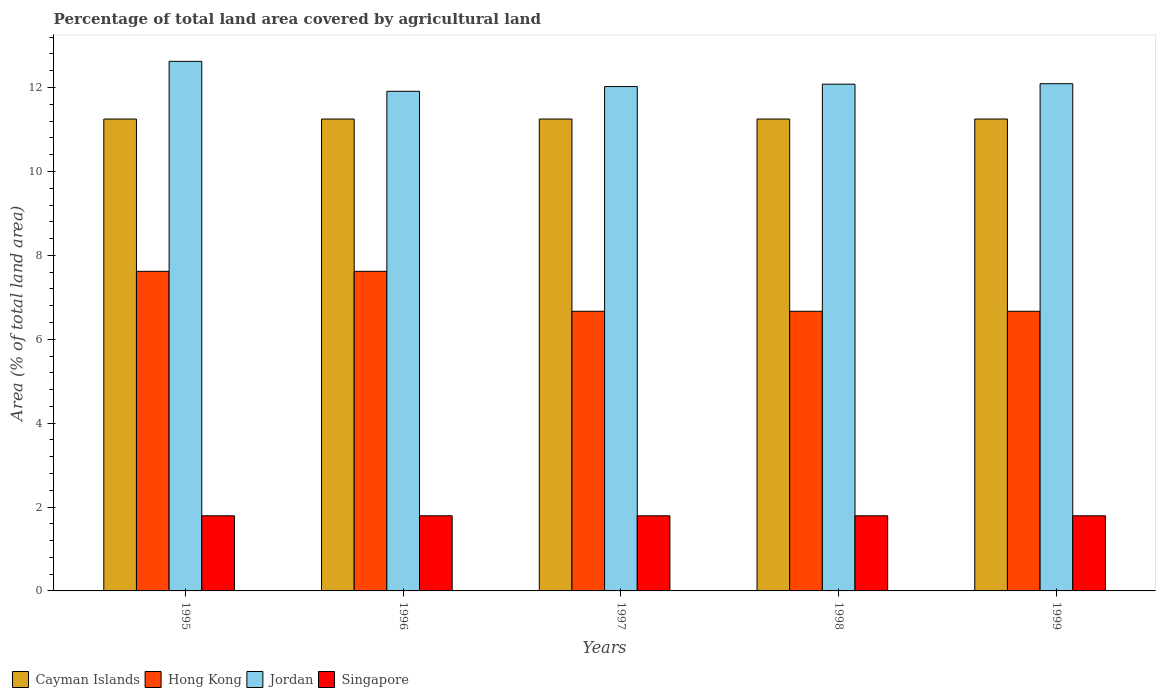How many groups of bars are there?
Give a very brief answer. 5. How many bars are there on the 1st tick from the left?
Offer a terse response. 4. How many bars are there on the 1st tick from the right?
Provide a succinct answer. 4. In how many cases, is the number of bars for a given year not equal to the number of legend labels?
Your answer should be compact. 0. What is the percentage of agricultural land in Hong Kong in 1997?
Your answer should be compact. 6.67. Across all years, what is the maximum percentage of agricultural land in Jordan?
Make the answer very short. 12.62. Across all years, what is the minimum percentage of agricultural land in Hong Kong?
Keep it short and to the point. 6.67. In which year was the percentage of agricultural land in Jordan maximum?
Make the answer very short. 1995. In which year was the percentage of agricultural land in Hong Kong minimum?
Provide a succinct answer. 1997. What is the total percentage of agricultural land in Jordan in the graph?
Your answer should be very brief. 60.73. What is the difference between the percentage of agricultural land in Jordan in 1998 and that in 1999?
Offer a terse response. -0.01. What is the difference between the percentage of agricultural land in Hong Kong in 1997 and the percentage of agricultural land in Jordan in 1999?
Offer a terse response. -5.43. What is the average percentage of agricultural land in Singapore per year?
Provide a succinct answer. 1.79. In the year 1997, what is the difference between the percentage of agricultural land in Cayman Islands and percentage of agricultural land in Jordan?
Offer a very short reply. -0.77. In how many years, is the percentage of agricultural land in Cayman Islands greater than 3.6 %?
Give a very brief answer. 5. Is the percentage of agricultural land in Jordan in 1995 less than that in 1997?
Make the answer very short. No. What is the difference between the highest and the lowest percentage of agricultural land in Singapore?
Offer a terse response. 0. Is it the case that in every year, the sum of the percentage of agricultural land in Jordan and percentage of agricultural land in Singapore is greater than the sum of percentage of agricultural land in Hong Kong and percentage of agricultural land in Cayman Islands?
Offer a terse response. No. What does the 1st bar from the left in 1998 represents?
Your response must be concise. Cayman Islands. What does the 4th bar from the right in 1999 represents?
Your answer should be compact. Cayman Islands. How many bars are there?
Your answer should be very brief. 20. Are the values on the major ticks of Y-axis written in scientific E-notation?
Offer a terse response. No. Does the graph contain any zero values?
Your response must be concise. No. Where does the legend appear in the graph?
Offer a very short reply. Bottom left. How many legend labels are there?
Ensure brevity in your answer.  4. How are the legend labels stacked?
Provide a succinct answer. Horizontal. What is the title of the graph?
Your answer should be very brief. Percentage of total land area covered by agricultural land. Does "St. Kitts and Nevis" appear as one of the legend labels in the graph?
Offer a very short reply. No. What is the label or title of the X-axis?
Give a very brief answer. Years. What is the label or title of the Y-axis?
Offer a very short reply. Area (% of total land area). What is the Area (% of total land area) in Cayman Islands in 1995?
Your response must be concise. 11.25. What is the Area (% of total land area) in Hong Kong in 1995?
Provide a short and direct response. 7.62. What is the Area (% of total land area) of Jordan in 1995?
Provide a short and direct response. 12.62. What is the Area (% of total land area) of Singapore in 1995?
Provide a short and direct response. 1.79. What is the Area (% of total land area) in Cayman Islands in 1996?
Give a very brief answer. 11.25. What is the Area (% of total land area) in Hong Kong in 1996?
Your answer should be very brief. 7.62. What is the Area (% of total land area) in Jordan in 1996?
Provide a succinct answer. 11.91. What is the Area (% of total land area) of Singapore in 1996?
Offer a terse response. 1.79. What is the Area (% of total land area) in Cayman Islands in 1997?
Offer a terse response. 11.25. What is the Area (% of total land area) in Hong Kong in 1997?
Offer a terse response. 6.67. What is the Area (% of total land area) of Jordan in 1997?
Provide a succinct answer. 12.02. What is the Area (% of total land area) in Singapore in 1997?
Your response must be concise. 1.79. What is the Area (% of total land area) of Cayman Islands in 1998?
Provide a succinct answer. 11.25. What is the Area (% of total land area) in Hong Kong in 1998?
Give a very brief answer. 6.67. What is the Area (% of total land area) in Jordan in 1998?
Your response must be concise. 12.08. What is the Area (% of total land area) of Singapore in 1998?
Give a very brief answer. 1.79. What is the Area (% of total land area) in Cayman Islands in 1999?
Keep it short and to the point. 11.25. What is the Area (% of total land area) of Hong Kong in 1999?
Your answer should be compact. 6.67. What is the Area (% of total land area) of Jordan in 1999?
Offer a very short reply. 12.09. What is the Area (% of total land area) in Singapore in 1999?
Make the answer very short. 1.79. Across all years, what is the maximum Area (% of total land area) of Cayman Islands?
Ensure brevity in your answer.  11.25. Across all years, what is the maximum Area (% of total land area) of Hong Kong?
Offer a very short reply. 7.62. Across all years, what is the maximum Area (% of total land area) of Jordan?
Ensure brevity in your answer.  12.62. Across all years, what is the maximum Area (% of total land area) of Singapore?
Keep it short and to the point. 1.79. Across all years, what is the minimum Area (% of total land area) of Cayman Islands?
Provide a short and direct response. 11.25. Across all years, what is the minimum Area (% of total land area) of Hong Kong?
Your answer should be very brief. 6.67. Across all years, what is the minimum Area (% of total land area) of Jordan?
Your answer should be very brief. 11.91. Across all years, what is the minimum Area (% of total land area) of Singapore?
Offer a very short reply. 1.79. What is the total Area (% of total land area) in Cayman Islands in the graph?
Make the answer very short. 56.25. What is the total Area (% of total land area) of Hong Kong in the graph?
Your answer should be compact. 35.24. What is the total Area (% of total land area) in Jordan in the graph?
Ensure brevity in your answer.  60.73. What is the total Area (% of total land area) of Singapore in the graph?
Make the answer very short. 8.96. What is the difference between the Area (% of total land area) of Cayman Islands in 1995 and that in 1996?
Offer a very short reply. 0. What is the difference between the Area (% of total land area) in Jordan in 1995 and that in 1996?
Your answer should be compact. 0.71. What is the difference between the Area (% of total land area) of Jordan in 1995 and that in 1997?
Keep it short and to the point. 0.6. What is the difference between the Area (% of total land area) of Singapore in 1995 and that in 1997?
Your response must be concise. 0. What is the difference between the Area (% of total land area) of Hong Kong in 1995 and that in 1998?
Your response must be concise. 0.95. What is the difference between the Area (% of total land area) of Jordan in 1995 and that in 1998?
Your response must be concise. 0.54. What is the difference between the Area (% of total land area) in Jordan in 1995 and that in 1999?
Offer a very short reply. 0.53. What is the difference between the Area (% of total land area) in Singapore in 1995 and that in 1999?
Offer a terse response. 0. What is the difference between the Area (% of total land area) in Jordan in 1996 and that in 1997?
Your answer should be very brief. -0.11. What is the difference between the Area (% of total land area) of Cayman Islands in 1996 and that in 1998?
Offer a very short reply. 0. What is the difference between the Area (% of total land area) in Jordan in 1996 and that in 1998?
Keep it short and to the point. -0.17. What is the difference between the Area (% of total land area) in Singapore in 1996 and that in 1998?
Offer a terse response. 0. What is the difference between the Area (% of total land area) of Jordan in 1996 and that in 1999?
Offer a very short reply. -0.18. What is the difference between the Area (% of total land area) of Singapore in 1996 and that in 1999?
Your answer should be very brief. 0. What is the difference between the Area (% of total land area) of Jordan in 1997 and that in 1998?
Keep it short and to the point. -0.06. What is the difference between the Area (% of total land area) in Cayman Islands in 1997 and that in 1999?
Your answer should be very brief. 0. What is the difference between the Area (% of total land area) in Jordan in 1997 and that in 1999?
Keep it short and to the point. -0.07. What is the difference between the Area (% of total land area) of Jordan in 1998 and that in 1999?
Offer a terse response. -0.01. What is the difference between the Area (% of total land area) in Singapore in 1998 and that in 1999?
Your answer should be compact. 0. What is the difference between the Area (% of total land area) of Cayman Islands in 1995 and the Area (% of total land area) of Hong Kong in 1996?
Your answer should be very brief. 3.63. What is the difference between the Area (% of total land area) in Cayman Islands in 1995 and the Area (% of total land area) in Jordan in 1996?
Make the answer very short. -0.66. What is the difference between the Area (% of total land area) of Cayman Islands in 1995 and the Area (% of total land area) of Singapore in 1996?
Give a very brief answer. 9.46. What is the difference between the Area (% of total land area) of Hong Kong in 1995 and the Area (% of total land area) of Jordan in 1996?
Offer a terse response. -4.29. What is the difference between the Area (% of total land area) in Hong Kong in 1995 and the Area (% of total land area) in Singapore in 1996?
Keep it short and to the point. 5.83. What is the difference between the Area (% of total land area) in Jordan in 1995 and the Area (% of total land area) in Singapore in 1996?
Your response must be concise. 10.83. What is the difference between the Area (% of total land area) in Cayman Islands in 1995 and the Area (% of total land area) in Hong Kong in 1997?
Give a very brief answer. 4.58. What is the difference between the Area (% of total land area) of Cayman Islands in 1995 and the Area (% of total land area) of Jordan in 1997?
Your answer should be very brief. -0.77. What is the difference between the Area (% of total land area) of Cayman Islands in 1995 and the Area (% of total land area) of Singapore in 1997?
Give a very brief answer. 9.46. What is the difference between the Area (% of total land area) of Hong Kong in 1995 and the Area (% of total land area) of Jordan in 1997?
Give a very brief answer. -4.41. What is the difference between the Area (% of total land area) of Hong Kong in 1995 and the Area (% of total land area) of Singapore in 1997?
Keep it short and to the point. 5.83. What is the difference between the Area (% of total land area) of Jordan in 1995 and the Area (% of total land area) of Singapore in 1997?
Provide a succinct answer. 10.83. What is the difference between the Area (% of total land area) of Cayman Islands in 1995 and the Area (% of total land area) of Hong Kong in 1998?
Offer a terse response. 4.58. What is the difference between the Area (% of total land area) in Cayman Islands in 1995 and the Area (% of total land area) in Jordan in 1998?
Your response must be concise. -0.83. What is the difference between the Area (% of total land area) in Cayman Islands in 1995 and the Area (% of total land area) in Singapore in 1998?
Provide a succinct answer. 9.46. What is the difference between the Area (% of total land area) of Hong Kong in 1995 and the Area (% of total land area) of Jordan in 1998?
Make the answer very short. -4.46. What is the difference between the Area (% of total land area) of Hong Kong in 1995 and the Area (% of total land area) of Singapore in 1998?
Provide a short and direct response. 5.83. What is the difference between the Area (% of total land area) in Jordan in 1995 and the Area (% of total land area) in Singapore in 1998?
Give a very brief answer. 10.83. What is the difference between the Area (% of total land area) of Cayman Islands in 1995 and the Area (% of total land area) of Hong Kong in 1999?
Keep it short and to the point. 4.58. What is the difference between the Area (% of total land area) of Cayman Islands in 1995 and the Area (% of total land area) of Jordan in 1999?
Provide a succinct answer. -0.84. What is the difference between the Area (% of total land area) in Cayman Islands in 1995 and the Area (% of total land area) in Singapore in 1999?
Make the answer very short. 9.46. What is the difference between the Area (% of total land area) in Hong Kong in 1995 and the Area (% of total land area) in Jordan in 1999?
Ensure brevity in your answer.  -4.47. What is the difference between the Area (% of total land area) of Hong Kong in 1995 and the Area (% of total land area) of Singapore in 1999?
Offer a terse response. 5.83. What is the difference between the Area (% of total land area) in Jordan in 1995 and the Area (% of total land area) in Singapore in 1999?
Your answer should be compact. 10.83. What is the difference between the Area (% of total land area) in Cayman Islands in 1996 and the Area (% of total land area) in Hong Kong in 1997?
Keep it short and to the point. 4.58. What is the difference between the Area (% of total land area) of Cayman Islands in 1996 and the Area (% of total land area) of Jordan in 1997?
Offer a terse response. -0.77. What is the difference between the Area (% of total land area) in Cayman Islands in 1996 and the Area (% of total land area) in Singapore in 1997?
Make the answer very short. 9.46. What is the difference between the Area (% of total land area) in Hong Kong in 1996 and the Area (% of total land area) in Jordan in 1997?
Your answer should be very brief. -4.41. What is the difference between the Area (% of total land area) of Hong Kong in 1996 and the Area (% of total land area) of Singapore in 1997?
Offer a terse response. 5.83. What is the difference between the Area (% of total land area) of Jordan in 1996 and the Area (% of total land area) of Singapore in 1997?
Make the answer very short. 10.12. What is the difference between the Area (% of total land area) of Cayman Islands in 1996 and the Area (% of total land area) of Hong Kong in 1998?
Keep it short and to the point. 4.58. What is the difference between the Area (% of total land area) in Cayman Islands in 1996 and the Area (% of total land area) in Jordan in 1998?
Your answer should be very brief. -0.83. What is the difference between the Area (% of total land area) of Cayman Islands in 1996 and the Area (% of total land area) of Singapore in 1998?
Make the answer very short. 9.46. What is the difference between the Area (% of total land area) in Hong Kong in 1996 and the Area (% of total land area) in Jordan in 1998?
Ensure brevity in your answer.  -4.46. What is the difference between the Area (% of total land area) in Hong Kong in 1996 and the Area (% of total land area) in Singapore in 1998?
Offer a very short reply. 5.83. What is the difference between the Area (% of total land area) in Jordan in 1996 and the Area (% of total land area) in Singapore in 1998?
Keep it short and to the point. 10.12. What is the difference between the Area (% of total land area) in Cayman Islands in 1996 and the Area (% of total land area) in Hong Kong in 1999?
Offer a terse response. 4.58. What is the difference between the Area (% of total land area) of Cayman Islands in 1996 and the Area (% of total land area) of Jordan in 1999?
Give a very brief answer. -0.84. What is the difference between the Area (% of total land area) of Cayman Islands in 1996 and the Area (% of total land area) of Singapore in 1999?
Ensure brevity in your answer.  9.46. What is the difference between the Area (% of total land area) in Hong Kong in 1996 and the Area (% of total land area) in Jordan in 1999?
Provide a succinct answer. -4.47. What is the difference between the Area (% of total land area) of Hong Kong in 1996 and the Area (% of total land area) of Singapore in 1999?
Make the answer very short. 5.83. What is the difference between the Area (% of total land area) in Jordan in 1996 and the Area (% of total land area) in Singapore in 1999?
Provide a short and direct response. 10.12. What is the difference between the Area (% of total land area) of Cayman Islands in 1997 and the Area (% of total land area) of Hong Kong in 1998?
Give a very brief answer. 4.58. What is the difference between the Area (% of total land area) of Cayman Islands in 1997 and the Area (% of total land area) of Jordan in 1998?
Offer a terse response. -0.83. What is the difference between the Area (% of total land area) of Cayman Islands in 1997 and the Area (% of total land area) of Singapore in 1998?
Provide a short and direct response. 9.46. What is the difference between the Area (% of total land area) of Hong Kong in 1997 and the Area (% of total land area) of Jordan in 1998?
Keep it short and to the point. -5.41. What is the difference between the Area (% of total land area) of Hong Kong in 1997 and the Area (% of total land area) of Singapore in 1998?
Offer a very short reply. 4.88. What is the difference between the Area (% of total land area) of Jordan in 1997 and the Area (% of total land area) of Singapore in 1998?
Ensure brevity in your answer.  10.23. What is the difference between the Area (% of total land area) in Cayman Islands in 1997 and the Area (% of total land area) in Hong Kong in 1999?
Provide a short and direct response. 4.58. What is the difference between the Area (% of total land area) of Cayman Islands in 1997 and the Area (% of total land area) of Jordan in 1999?
Your response must be concise. -0.84. What is the difference between the Area (% of total land area) in Cayman Islands in 1997 and the Area (% of total land area) in Singapore in 1999?
Make the answer very short. 9.46. What is the difference between the Area (% of total land area) in Hong Kong in 1997 and the Area (% of total land area) in Jordan in 1999?
Your response must be concise. -5.43. What is the difference between the Area (% of total land area) of Hong Kong in 1997 and the Area (% of total land area) of Singapore in 1999?
Keep it short and to the point. 4.88. What is the difference between the Area (% of total land area) of Jordan in 1997 and the Area (% of total land area) of Singapore in 1999?
Make the answer very short. 10.23. What is the difference between the Area (% of total land area) of Cayman Islands in 1998 and the Area (% of total land area) of Hong Kong in 1999?
Provide a succinct answer. 4.58. What is the difference between the Area (% of total land area) in Cayman Islands in 1998 and the Area (% of total land area) in Jordan in 1999?
Give a very brief answer. -0.84. What is the difference between the Area (% of total land area) of Cayman Islands in 1998 and the Area (% of total land area) of Singapore in 1999?
Your answer should be compact. 9.46. What is the difference between the Area (% of total land area) of Hong Kong in 1998 and the Area (% of total land area) of Jordan in 1999?
Make the answer very short. -5.43. What is the difference between the Area (% of total land area) in Hong Kong in 1998 and the Area (% of total land area) in Singapore in 1999?
Give a very brief answer. 4.88. What is the difference between the Area (% of total land area) of Jordan in 1998 and the Area (% of total land area) of Singapore in 1999?
Offer a terse response. 10.29. What is the average Area (% of total land area) of Cayman Islands per year?
Give a very brief answer. 11.25. What is the average Area (% of total land area) of Hong Kong per year?
Offer a very short reply. 7.05. What is the average Area (% of total land area) in Jordan per year?
Offer a very short reply. 12.15. What is the average Area (% of total land area) in Singapore per year?
Provide a succinct answer. 1.79. In the year 1995, what is the difference between the Area (% of total land area) of Cayman Islands and Area (% of total land area) of Hong Kong?
Offer a terse response. 3.63. In the year 1995, what is the difference between the Area (% of total land area) in Cayman Islands and Area (% of total land area) in Jordan?
Your response must be concise. -1.37. In the year 1995, what is the difference between the Area (% of total land area) of Cayman Islands and Area (% of total land area) of Singapore?
Make the answer very short. 9.46. In the year 1995, what is the difference between the Area (% of total land area) of Hong Kong and Area (% of total land area) of Jordan?
Give a very brief answer. -5.01. In the year 1995, what is the difference between the Area (% of total land area) of Hong Kong and Area (% of total land area) of Singapore?
Your response must be concise. 5.83. In the year 1995, what is the difference between the Area (% of total land area) in Jordan and Area (% of total land area) in Singapore?
Give a very brief answer. 10.83. In the year 1996, what is the difference between the Area (% of total land area) of Cayman Islands and Area (% of total land area) of Hong Kong?
Your answer should be very brief. 3.63. In the year 1996, what is the difference between the Area (% of total land area) in Cayman Islands and Area (% of total land area) in Jordan?
Provide a short and direct response. -0.66. In the year 1996, what is the difference between the Area (% of total land area) in Cayman Islands and Area (% of total land area) in Singapore?
Your answer should be very brief. 9.46. In the year 1996, what is the difference between the Area (% of total land area) in Hong Kong and Area (% of total land area) in Jordan?
Keep it short and to the point. -4.29. In the year 1996, what is the difference between the Area (% of total land area) of Hong Kong and Area (% of total land area) of Singapore?
Provide a succinct answer. 5.83. In the year 1996, what is the difference between the Area (% of total land area) in Jordan and Area (% of total land area) in Singapore?
Provide a short and direct response. 10.12. In the year 1997, what is the difference between the Area (% of total land area) of Cayman Islands and Area (% of total land area) of Hong Kong?
Your answer should be very brief. 4.58. In the year 1997, what is the difference between the Area (% of total land area) in Cayman Islands and Area (% of total land area) in Jordan?
Provide a short and direct response. -0.77. In the year 1997, what is the difference between the Area (% of total land area) in Cayman Islands and Area (% of total land area) in Singapore?
Your answer should be very brief. 9.46. In the year 1997, what is the difference between the Area (% of total land area) in Hong Kong and Area (% of total land area) in Jordan?
Provide a short and direct response. -5.36. In the year 1997, what is the difference between the Area (% of total land area) of Hong Kong and Area (% of total land area) of Singapore?
Your answer should be compact. 4.88. In the year 1997, what is the difference between the Area (% of total land area) in Jordan and Area (% of total land area) in Singapore?
Offer a terse response. 10.23. In the year 1998, what is the difference between the Area (% of total land area) of Cayman Islands and Area (% of total land area) of Hong Kong?
Keep it short and to the point. 4.58. In the year 1998, what is the difference between the Area (% of total land area) of Cayman Islands and Area (% of total land area) of Jordan?
Your response must be concise. -0.83. In the year 1998, what is the difference between the Area (% of total land area) in Cayman Islands and Area (% of total land area) in Singapore?
Offer a very short reply. 9.46. In the year 1998, what is the difference between the Area (% of total land area) in Hong Kong and Area (% of total land area) in Jordan?
Give a very brief answer. -5.41. In the year 1998, what is the difference between the Area (% of total land area) in Hong Kong and Area (% of total land area) in Singapore?
Your answer should be very brief. 4.88. In the year 1998, what is the difference between the Area (% of total land area) in Jordan and Area (% of total land area) in Singapore?
Your response must be concise. 10.29. In the year 1999, what is the difference between the Area (% of total land area) in Cayman Islands and Area (% of total land area) in Hong Kong?
Keep it short and to the point. 4.58. In the year 1999, what is the difference between the Area (% of total land area) in Cayman Islands and Area (% of total land area) in Jordan?
Give a very brief answer. -0.84. In the year 1999, what is the difference between the Area (% of total land area) in Cayman Islands and Area (% of total land area) in Singapore?
Keep it short and to the point. 9.46. In the year 1999, what is the difference between the Area (% of total land area) in Hong Kong and Area (% of total land area) in Jordan?
Offer a terse response. -5.43. In the year 1999, what is the difference between the Area (% of total land area) in Hong Kong and Area (% of total land area) in Singapore?
Your answer should be very brief. 4.88. In the year 1999, what is the difference between the Area (% of total land area) in Jordan and Area (% of total land area) in Singapore?
Your answer should be compact. 10.3. What is the ratio of the Area (% of total land area) of Cayman Islands in 1995 to that in 1996?
Provide a succinct answer. 1. What is the ratio of the Area (% of total land area) of Jordan in 1995 to that in 1996?
Make the answer very short. 1.06. What is the ratio of the Area (% of total land area) in Jordan in 1995 to that in 1998?
Offer a very short reply. 1.04. What is the ratio of the Area (% of total land area) in Singapore in 1995 to that in 1998?
Make the answer very short. 1. What is the ratio of the Area (% of total land area) of Cayman Islands in 1995 to that in 1999?
Keep it short and to the point. 1. What is the ratio of the Area (% of total land area) in Jordan in 1995 to that in 1999?
Keep it short and to the point. 1.04. What is the ratio of the Area (% of total land area) of Jordan in 1996 to that in 1997?
Your response must be concise. 0.99. What is the ratio of the Area (% of total land area) of Singapore in 1996 to that in 1997?
Give a very brief answer. 1. What is the ratio of the Area (% of total land area) in Cayman Islands in 1996 to that in 1998?
Your response must be concise. 1. What is the ratio of the Area (% of total land area) of Jordan in 1996 to that in 1998?
Keep it short and to the point. 0.99. What is the ratio of the Area (% of total land area) of Singapore in 1996 to that in 1998?
Provide a short and direct response. 1. What is the ratio of the Area (% of total land area) in Jordan in 1996 to that in 1999?
Provide a short and direct response. 0.98. What is the ratio of the Area (% of total land area) of Cayman Islands in 1997 to that in 1998?
Provide a succinct answer. 1. What is the ratio of the Area (% of total land area) of Hong Kong in 1997 to that in 1998?
Give a very brief answer. 1. What is the ratio of the Area (% of total land area) in Cayman Islands in 1997 to that in 1999?
Provide a short and direct response. 1. What is the ratio of the Area (% of total land area) in Hong Kong in 1997 to that in 1999?
Offer a terse response. 1. What is the ratio of the Area (% of total land area) of Cayman Islands in 1998 to that in 1999?
Your response must be concise. 1. What is the ratio of the Area (% of total land area) in Jordan in 1998 to that in 1999?
Make the answer very short. 1. What is the difference between the highest and the second highest Area (% of total land area) in Cayman Islands?
Offer a terse response. 0. What is the difference between the highest and the second highest Area (% of total land area) in Jordan?
Provide a succinct answer. 0.53. What is the difference between the highest and the lowest Area (% of total land area) of Jordan?
Make the answer very short. 0.71. 